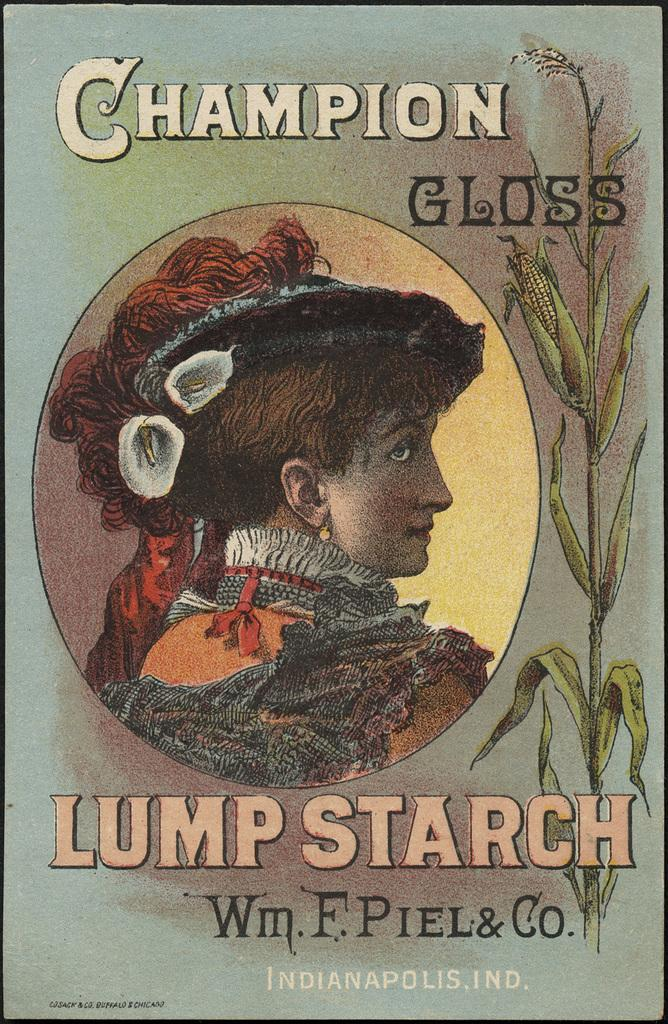<image>
Give a short and clear explanation of the subsequent image. The book shown is written by the author Lump Starch. 